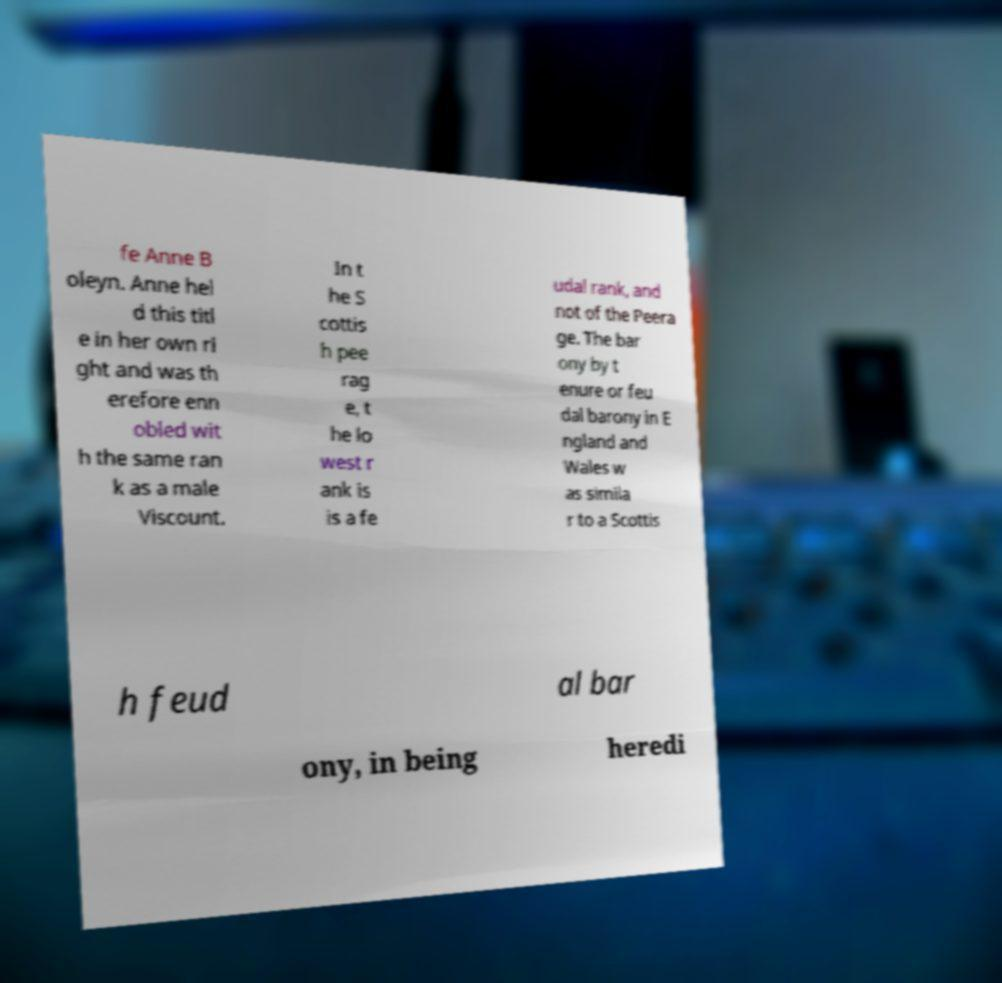Could you extract and type out the text from this image? fe Anne B oleyn. Anne hel d this titl e in her own ri ght and was th erefore enn obled wit h the same ran k as a male Viscount. In t he S cottis h pee rag e, t he lo west r ank is is a fe udal rank, and not of the Peera ge. The bar ony by t enure or feu dal barony in E ngland and Wales w as simila r to a Scottis h feud al bar ony, in being heredi 